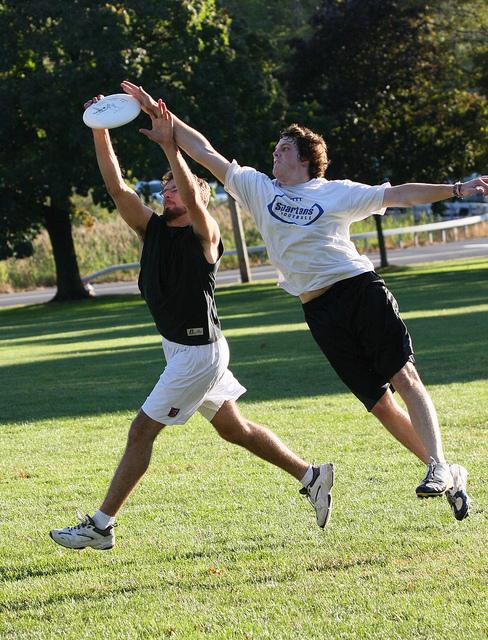The player wearing what color of shirt is likely to catch the frisbee? Please explain your reasoning. black. The person in black is closer to the frisbee and his hands are closer to it as well. 